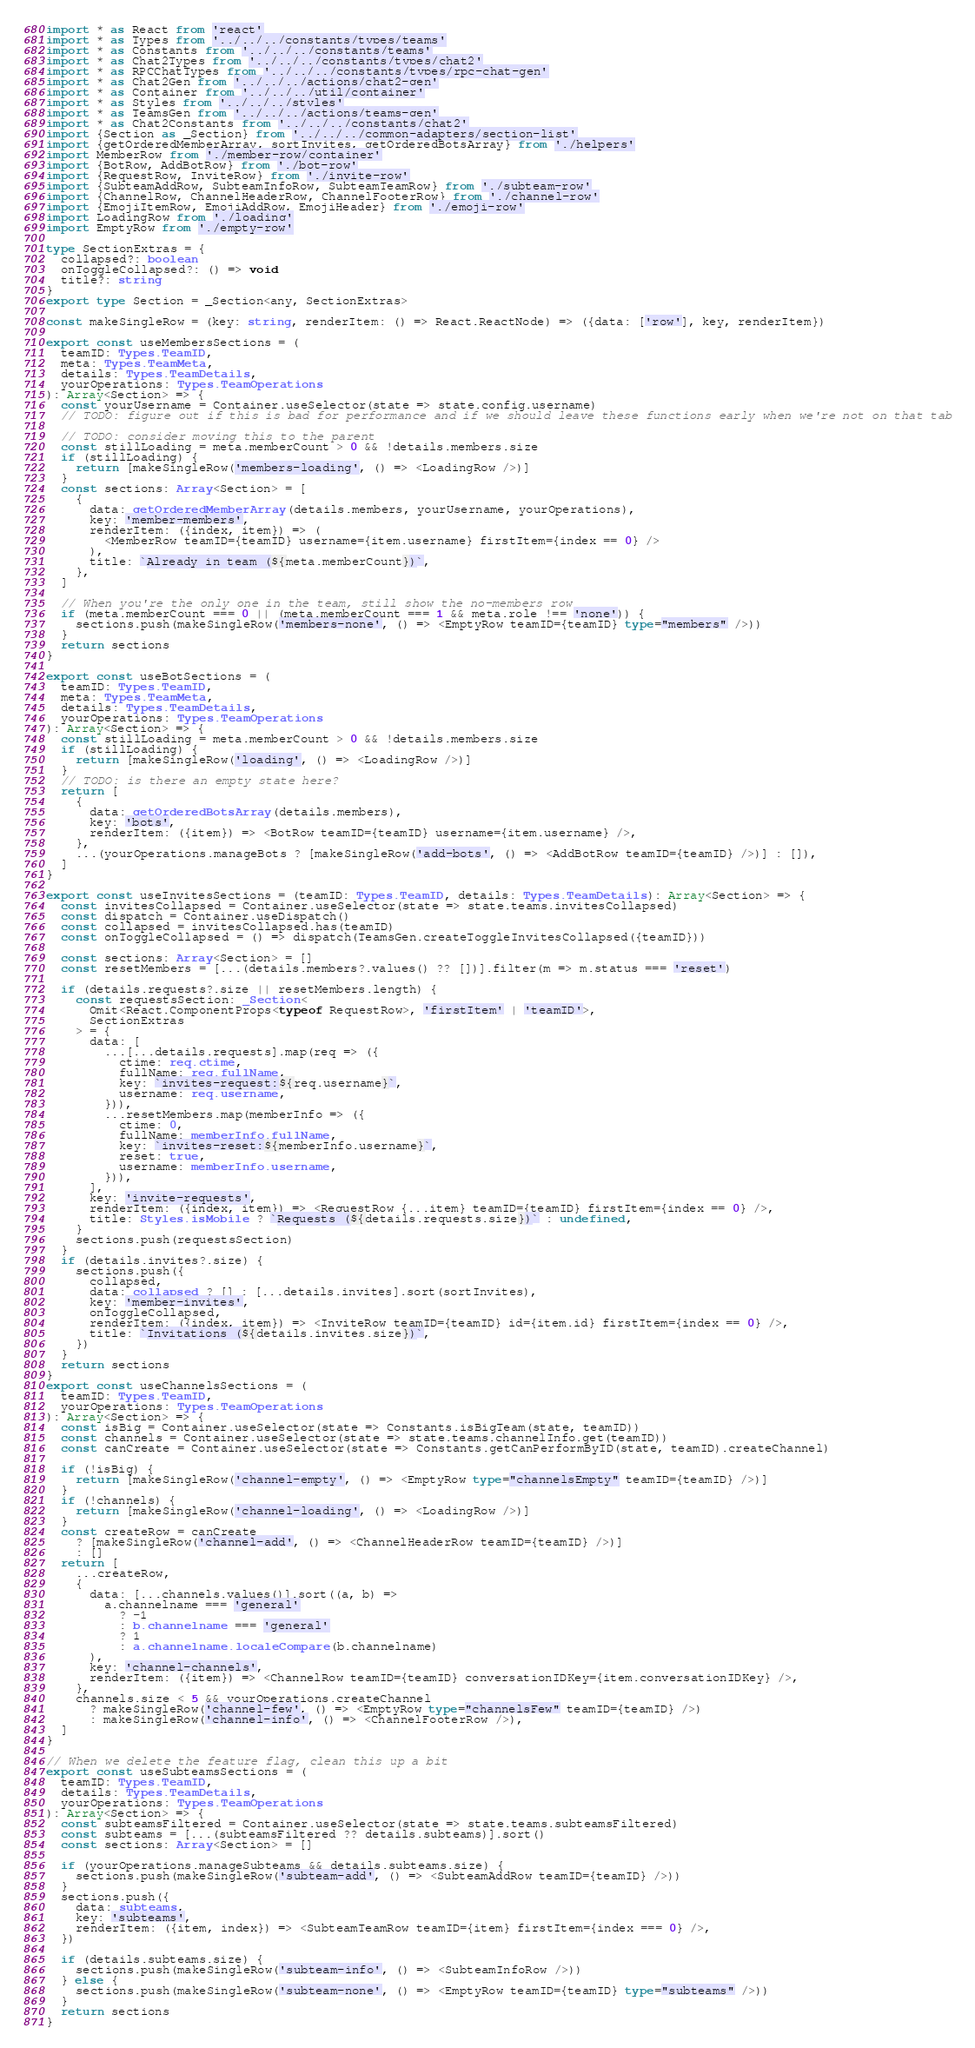<code> <loc_0><loc_0><loc_500><loc_500><_TypeScript_>import * as React from 'react'
import * as Types from '../../../constants/types/teams'
import * as Constants from '../../../constants/teams'
import * as Chat2Types from '../../../constants/types/chat2'
import * as RPCChatTypes from '../../../constants/types/rpc-chat-gen'
import * as Chat2Gen from '../../../actions/chat2-gen'
import * as Container from '../../../util/container'
import * as Styles from '../../../styles'
import * as TeamsGen from '../../../actions/teams-gen'
import * as Chat2Constants from '../../../constants/chat2'
import {Section as _Section} from '../../../common-adapters/section-list'
import {getOrderedMemberArray, sortInvites, getOrderedBotsArray} from './helpers'
import MemberRow from './member-row/container'
import {BotRow, AddBotRow} from './bot-row'
import {RequestRow, InviteRow} from './invite-row'
import {SubteamAddRow, SubteamInfoRow, SubteamTeamRow} from './subteam-row'
import {ChannelRow, ChannelHeaderRow, ChannelFooterRow} from './channel-row'
import {EmojiItemRow, EmojiAddRow, EmojiHeader} from './emoji-row'
import LoadingRow from './loading'
import EmptyRow from './empty-row'

type SectionExtras = {
  collapsed?: boolean
  onToggleCollapsed?: () => void
  title?: string
}
export type Section = _Section<any, SectionExtras>

const makeSingleRow = (key: string, renderItem: () => React.ReactNode) => ({data: ['row'], key, renderItem})

export const useMembersSections = (
  teamID: Types.TeamID,
  meta: Types.TeamMeta,
  details: Types.TeamDetails,
  yourOperations: Types.TeamOperations
): Array<Section> => {
  const yourUsername = Container.useSelector(state => state.config.username)
  // TODO: figure out if this is bad for performance and if we should leave these functions early when we're not on that tab

  // TODO: consider moving this to the parent
  const stillLoading = meta.memberCount > 0 && !details.members.size
  if (stillLoading) {
    return [makeSingleRow('members-loading', () => <LoadingRow />)]
  }
  const sections: Array<Section> = [
    {
      data: getOrderedMemberArray(details.members, yourUsername, yourOperations),
      key: 'member-members',
      renderItem: ({index, item}) => (
        <MemberRow teamID={teamID} username={item.username} firstItem={index == 0} />
      ),
      title: `Already in team (${meta.memberCount})`,
    },
  ]

  // When you're the only one in the team, still show the no-members row
  if (meta.memberCount === 0 || (meta.memberCount === 1 && meta.role !== 'none')) {
    sections.push(makeSingleRow('members-none', () => <EmptyRow teamID={teamID} type="members" />))
  }
  return sections
}

export const useBotSections = (
  teamID: Types.TeamID,
  meta: Types.TeamMeta,
  details: Types.TeamDetails,
  yourOperations: Types.TeamOperations
): Array<Section> => {
  const stillLoading = meta.memberCount > 0 && !details.members.size
  if (stillLoading) {
    return [makeSingleRow('loading', () => <LoadingRow />)]
  }
  // TODO: is there an empty state here?
  return [
    {
      data: getOrderedBotsArray(details.members),
      key: 'bots',
      renderItem: ({item}) => <BotRow teamID={teamID} username={item.username} />,
    },
    ...(yourOperations.manageBots ? [makeSingleRow('add-bots', () => <AddBotRow teamID={teamID} />)] : []),
  ]
}

export const useInvitesSections = (teamID: Types.TeamID, details: Types.TeamDetails): Array<Section> => {
  const invitesCollapsed = Container.useSelector(state => state.teams.invitesCollapsed)
  const dispatch = Container.useDispatch()
  const collapsed = invitesCollapsed.has(teamID)
  const onToggleCollapsed = () => dispatch(TeamsGen.createToggleInvitesCollapsed({teamID}))

  const sections: Array<Section> = []
  const resetMembers = [...(details.members?.values() ?? [])].filter(m => m.status === 'reset')

  if (details.requests?.size || resetMembers.length) {
    const requestsSection: _Section<
      Omit<React.ComponentProps<typeof RequestRow>, 'firstItem' | 'teamID'>,
      SectionExtras
    > = {
      data: [
        ...[...details.requests].map(req => ({
          ctime: req.ctime,
          fullName: req.fullName,
          key: `invites-request:${req.username}`,
          username: req.username,
        })),
        ...resetMembers.map(memberInfo => ({
          ctime: 0,
          fullName: memberInfo.fullName,
          key: `invites-reset:${memberInfo.username}`,
          reset: true,
          username: memberInfo.username,
        })),
      ],
      key: 'invite-requests',
      renderItem: ({index, item}) => <RequestRow {...item} teamID={teamID} firstItem={index == 0} />,
      title: Styles.isMobile ? `Requests (${details.requests.size})` : undefined,
    }
    sections.push(requestsSection)
  }
  if (details.invites?.size) {
    sections.push({
      collapsed,
      data: collapsed ? [] : [...details.invites].sort(sortInvites),
      key: 'member-invites',
      onToggleCollapsed,
      renderItem: ({index, item}) => <InviteRow teamID={teamID} id={item.id} firstItem={index == 0} />,
      title: `Invitations (${details.invites.size})`,
    })
  }
  return sections
}
export const useChannelsSections = (
  teamID: Types.TeamID,
  yourOperations: Types.TeamOperations
): Array<Section> => {
  const isBig = Container.useSelector(state => Constants.isBigTeam(state, teamID))
  const channels = Container.useSelector(state => state.teams.channelInfo.get(teamID))
  const canCreate = Container.useSelector(state => Constants.getCanPerformByID(state, teamID).createChannel)

  if (!isBig) {
    return [makeSingleRow('channel-empty', () => <EmptyRow type="channelsEmpty" teamID={teamID} />)]
  }
  if (!channels) {
    return [makeSingleRow('channel-loading', () => <LoadingRow />)]
  }
  const createRow = canCreate
    ? [makeSingleRow('channel-add', () => <ChannelHeaderRow teamID={teamID} />)]
    : []
  return [
    ...createRow,
    {
      data: [...channels.values()].sort((a, b) =>
        a.channelname === 'general'
          ? -1
          : b.channelname === 'general'
          ? 1
          : a.channelname.localeCompare(b.channelname)
      ),
      key: 'channel-channels',
      renderItem: ({item}) => <ChannelRow teamID={teamID} conversationIDKey={item.conversationIDKey} />,
    },
    channels.size < 5 && yourOperations.createChannel
      ? makeSingleRow('channel-few', () => <EmptyRow type="channelsFew" teamID={teamID} />)
      : makeSingleRow('channel-info', () => <ChannelFooterRow />),
  ]
}

// When we delete the feature flag, clean this up a bit
export const useSubteamsSections = (
  teamID: Types.TeamID,
  details: Types.TeamDetails,
  yourOperations: Types.TeamOperations
): Array<Section> => {
  const subteamsFiltered = Container.useSelector(state => state.teams.subteamsFiltered)
  const subteams = [...(subteamsFiltered ?? details.subteams)].sort()
  const sections: Array<Section> = []

  if (yourOperations.manageSubteams && details.subteams.size) {
    sections.push(makeSingleRow('subteam-add', () => <SubteamAddRow teamID={teamID} />))
  }
  sections.push({
    data: subteams,
    key: 'subteams',
    renderItem: ({item, index}) => <SubteamTeamRow teamID={item} firstItem={index === 0} />,
  })

  if (details.subteams.size) {
    sections.push(makeSingleRow('subteam-info', () => <SubteamInfoRow />))
  } else {
    sections.push(makeSingleRow('subteam-none', () => <EmptyRow teamID={teamID} type="subteams" />))
  }
  return sections
}
</code> 